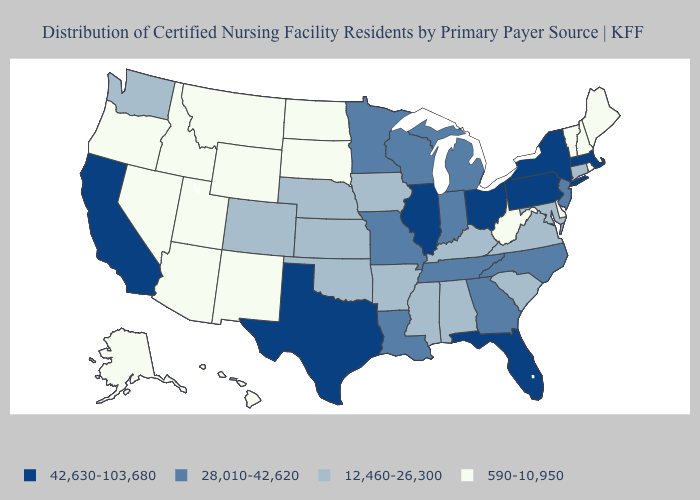Does Virginia have the highest value in the South?
Write a very short answer. No. Name the states that have a value in the range 42,630-103,680?
Write a very short answer. California, Florida, Illinois, Massachusetts, New York, Ohio, Pennsylvania, Texas. What is the value of Maine?
Keep it brief. 590-10,950. How many symbols are there in the legend?
Short answer required. 4. Among the states that border West Virginia , does Kentucky have the highest value?
Give a very brief answer. No. Is the legend a continuous bar?
Write a very short answer. No. Name the states that have a value in the range 590-10,950?
Write a very short answer. Alaska, Arizona, Delaware, Hawaii, Idaho, Maine, Montana, Nevada, New Hampshire, New Mexico, North Dakota, Oregon, Rhode Island, South Dakota, Utah, Vermont, West Virginia, Wyoming. Among the states that border Oklahoma , does Texas have the highest value?
Answer briefly. Yes. What is the value of New Jersey?
Be succinct. 28,010-42,620. Does Maine have the same value as Kansas?
Short answer required. No. Among the states that border Illinois , does Iowa have the highest value?
Write a very short answer. No. Name the states that have a value in the range 28,010-42,620?
Short answer required. Georgia, Indiana, Louisiana, Michigan, Minnesota, Missouri, New Jersey, North Carolina, Tennessee, Wisconsin. Does Idaho have a higher value than Alaska?
Quick response, please. No. Name the states that have a value in the range 12,460-26,300?
Write a very short answer. Alabama, Arkansas, Colorado, Connecticut, Iowa, Kansas, Kentucky, Maryland, Mississippi, Nebraska, Oklahoma, South Carolina, Virginia, Washington. Which states have the lowest value in the MidWest?
Be succinct. North Dakota, South Dakota. 